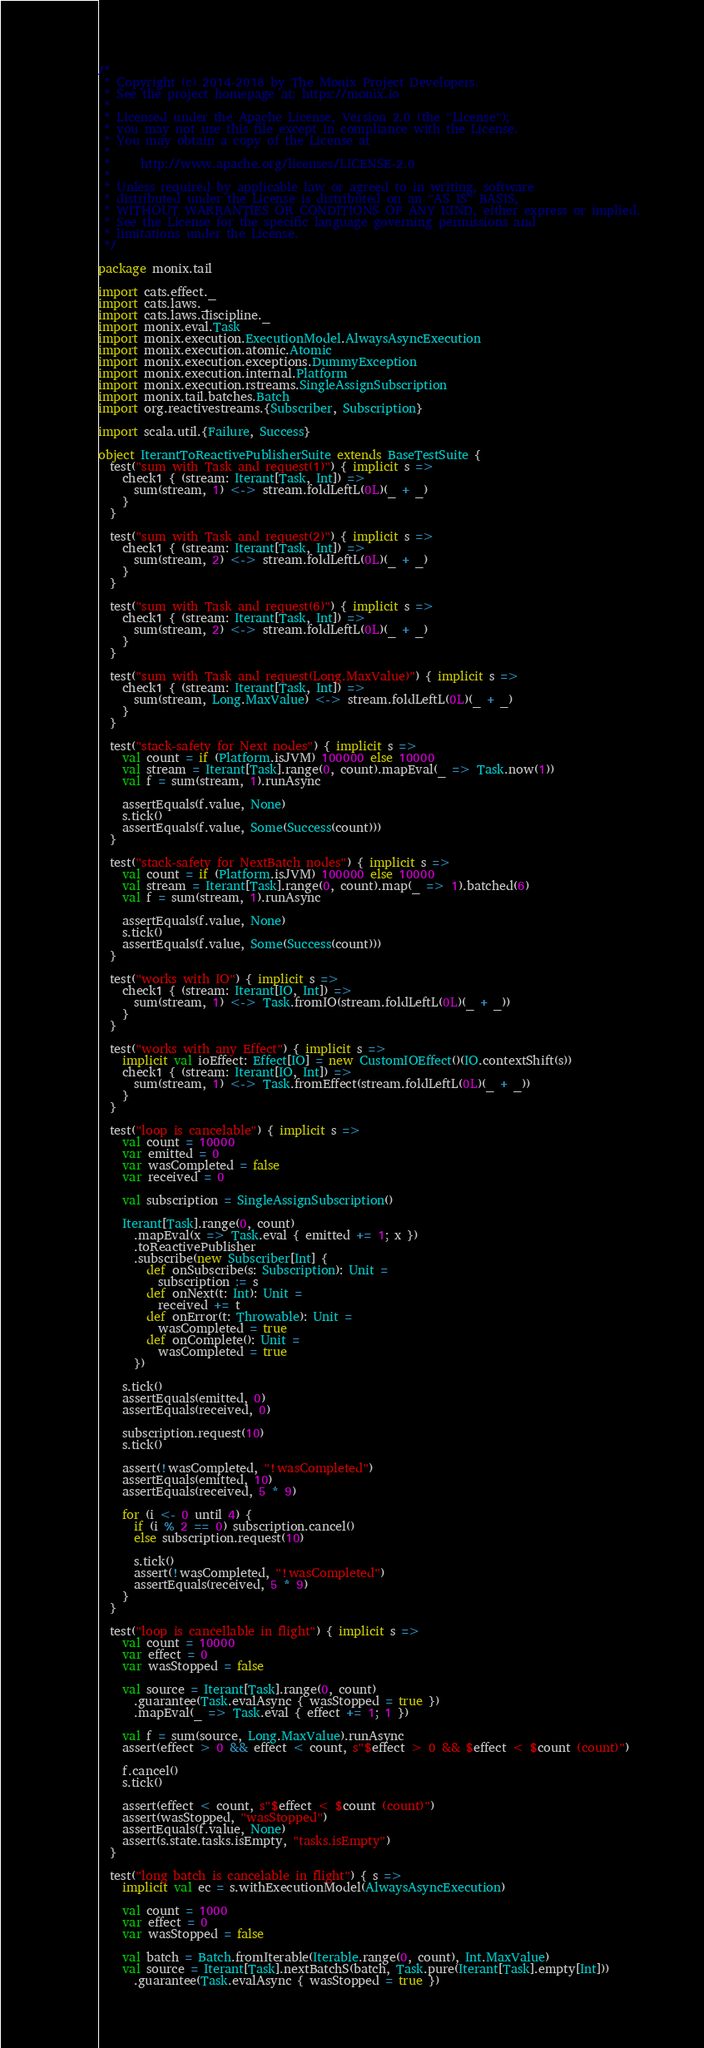Convert code to text. <code><loc_0><loc_0><loc_500><loc_500><_Scala_>/*
 * Copyright (c) 2014-2018 by The Monix Project Developers.
 * See the project homepage at: https://monix.io
 *
 * Licensed under the Apache License, Version 2.0 (the "License");
 * you may not use this file except in compliance with the License.
 * You may obtain a copy of the License at
 *
 *     http://www.apache.org/licenses/LICENSE-2.0
 *
 * Unless required by applicable law or agreed to in writing, software
 * distributed under the License is distributed on an "AS IS" BASIS,
 * WITHOUT WARRANTIES OR CONDITIONS OF ANY KIND, either express or implied.
 * See the License for the specific language governing permissions and
 * limitations under the License.
 */

package monix.tail

import cats.effect._
import cats.laws._
import cats.laws.discipline._
import monix.eval.Task
import monix.execution.ExecutionModel.AlwaysAsyncExecution
import monix.execution.atomic.Atomic
import monix.execution.exceptions.DummyException
import monix.execution.internal.Platform
import monix.execution.rstreams.SingleAssignSubscription
import monix.tail.batches.Batch
import org.reactivestreams.{Subscriber, Subscription}

import scala.util.{Failure, Success}

object IterantToReactivePublisherSuite extends BaseTestSuite {
  test("sum with Task and request(1)") { implicit s =>
    check1 { (stream: Iterant[Task, Int]) =>
      sum(stream, 1) <-> stream.foldLeftL(0L)(_ + _)
    }
  }

  test("sum with Task and request(2)") { implicit s =>
    check1 { (stream: Iterant[Task, Int]) =>
      sum(stream, 2) <-> stream.foldLeftL(0L)(_ + _)
    }
  }

  test("sum with Task and request(6)") { implicit s =>
    check1 { (stream: Iterant[Task, Int]) =>
      sum(stream, 2) <-> stream.foldLeftL(0L)(_ + _)
    }
  }

  test("sum with Task and request(Long.MaxValue)") { implicit s =>
    check1 { (stream: Iterant[Task, Int]) =>
      sum(stream, Long.MaxValue) <-> stream.foldLeftL(0L)(_ + _)
    }
  }

  test("stack-safety for Next nodes") { implicit s =>
    val count = if (Platform.isJVM) 100000 else 10000
    val stream = Iterant[Task].range(0, count).mapEval(_ => Task.now(1))
    val f = sum(stream, 1).runAsync

    assertEquals(f.value, None)
    s.tick()
    assertEquals(f.value, Some(Success(count)))
  }

  test("stack-safety for NextBatch nodes") { implicit s =>
    val count = if (Platform.isJVM) 100000 else 10000
    val stream = Iterant[Task].range(0, count).map(_ => 1).batched(6)
    val f = sum(stream, 1).runAsync

    assertEquals(f.value, None)
    s.tick()
    assertEquals(f.value, Some(Success(count)))
  }

  test("works with IO") { implicit s =>
    check1 { (stream: Iterant[IO, Int]) =>
      sum(stream, 1) <-> Task.fromIO(stream.foldLeftL(0L)(_ + _))
    }
  }

  test("works with any Effect") { implicit s =>
    implicit val ioEffect: Effect[IO] = new CustomIOEffect()(IO.contextShift(s))
    check1 { (stream: Iterant[IO, Int]) =>
      sum(stream, 1) <-> Task.fromEffect(stream.foldLeftL(0L)(_ + _))
    }
  }

  test("loop is cancelable") { implicit s =>
    val count = 10000
    var emitted = 0
    var wasCompleted = false
    var received = 0

    val subscription = SingleAssignSubscription()

    Iterant[Task].range(0, count)
      .mapEval(x => Task.eval { emitted += 1; x })
      .toReactivePublisher
      .subscribe(new Subscriber[Int] {
        def onSubscribe(s: Subscription): Unit =
          subscription := s
        def onNext(t: Int): Unit =
          received += t
        def onError(t: Throwable): Unit =
          wasCompleted = true
        def onComplete(): Unit =
          wasCompleted = true
      })

    s.tick()
    assertEquals(emitted, 0)
    assertEquals(received, 0)

    subscription.request(10)
    s.tick()

    assert(!wasCompleted, "!wasCompleted")
    assertEquals(emitted, 10)
    assertEquals(received, 5 * 9)

    for (i <- 0 until 4) {
      if (i % 2 == 0) subscription.cancel()
      else subscription.request(10)

      s.tick()
      assert(!wasCompleted, "!wasCompleted")
      assertEquals(received, 5 * 9)
    }
  }

  test("loop is cancellable in flight") { implicit s =>
    val count = 10000
    var effect = 0
    var wasStopped = false

    val source = Iterant[Task].range(0, count)
      .guarantee(Task.evalAsync { wasStopped = true })
      .mapEval(_ => Task.eval { effect += 1; 1 })

    val f = sum(source, Long.MaxValue).runAsync
    assert(effect > 0 && effect < count, s"$effect > 0 && $effect < $count (count)")

    f.cancel()
    s.tick()

    assert(effect < count, s"$effect < $count (count)")
    assert(wasStopped, "wasStopped")
    assertEquals(f.value, None)
    assert(s.state.tasks.isEmpty, "tasks.isEmpty")
  }

  test("long batch is cancelable in flight") { s =>
    implicit val ec = s.withExecutionModel(AlwaysAsyncExecution)

    val count = 1000
    var effect = 0
    var wasStopped = false

    val batch = Batch.fromIterable(Iterable.range(0, count), Int.MaxValue)
    val source = Iterant[Task].nextBatchS(batch, Task.pure(Iterant[Task].empty[Int]))
      .guarantee(Task.evalAsync { wasStopped = true })</code> 